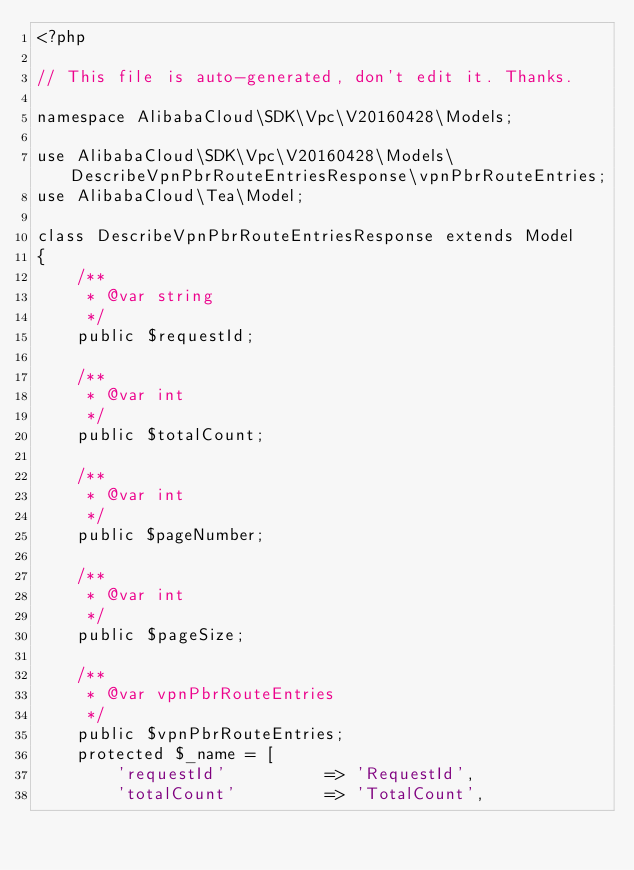Convert code to text. <code><loc_0><loc_0><loc_500><loc_500><_PHP_><?php

// This file is auto-generated, don't edit it. Thanks.

namespace AlibabaCloud\SDK\Vpc\V20160428\Models;

use AlibabaCloud\SDK\Vpc\V20160428\Models\DescribeVpnPbrRouteEntriesResponse\vpnPbrRouteEntries;
use AlibabaCloud\Tea\Model;

class DescribeVpnPbrRouteEntriesResponse extends Model
{
    /**
     * @var string
     */
    public $requestId;

    /**
     * @var int
     */
    public $totalCount;

    /**
     * @var int
     */
    public $pageNumber;

    /**
     * @var int
     */
    public $pageSize;

    /**
     * @var vpnPbrRouteEntries
     */
    public $vpnPbrRouteEntries;
    protected $_name = [
        'requestId'          => 'RequestId',
        'totalCount'         => 'TotalCount',</code> 